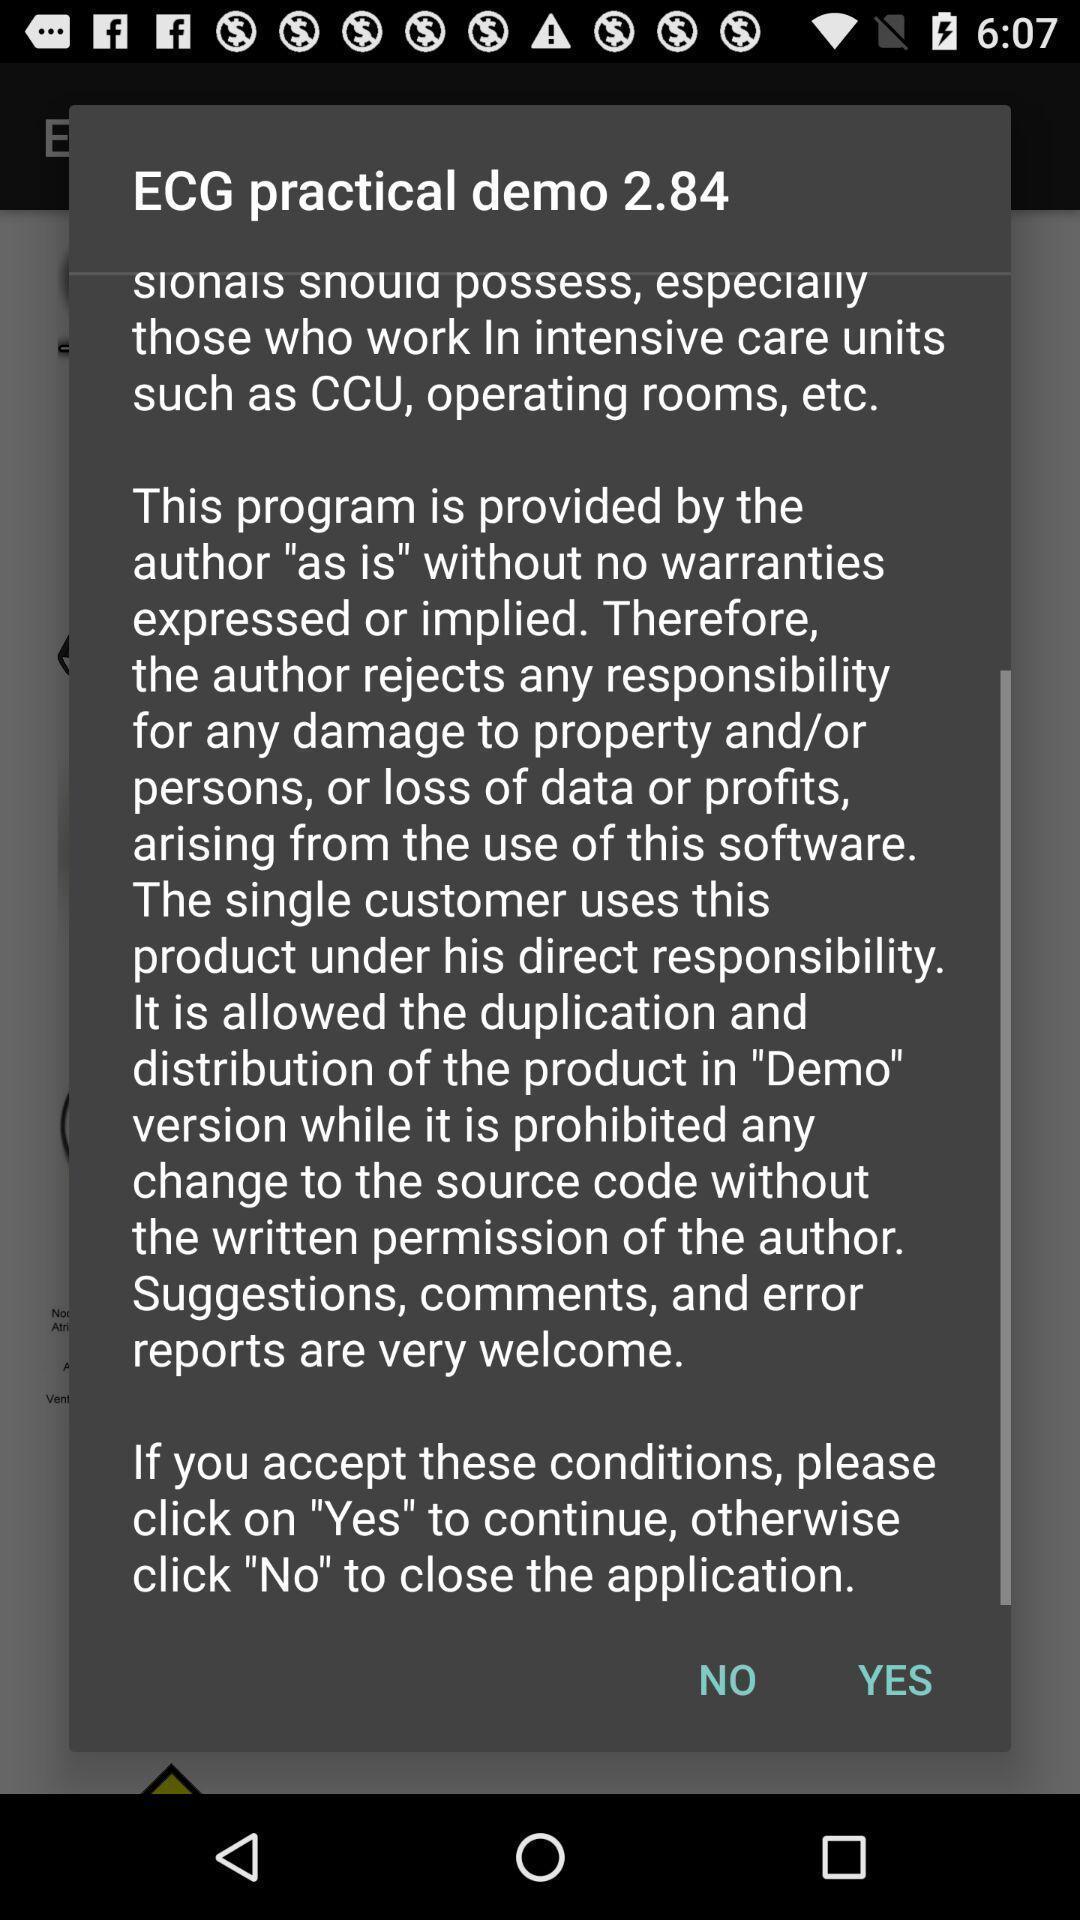Tell me about the visual elements in this screen capture. Popup displaying terms and conditions information. 